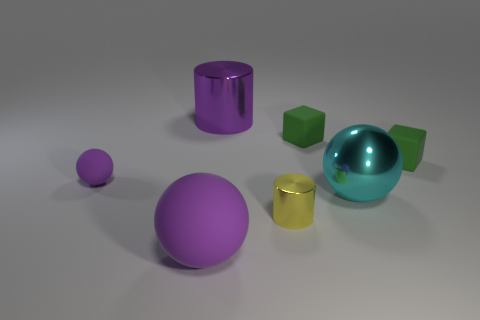What color is the big sphere behind the yellow thing?
Provide a succinct answer. Cyan. How many objects are large metallic things in front of the tiny sphere or yellow metallic cylinders?
Offer a very short reply. 2. What is the color of the metallic ball that is the same size as the purple shiny cylinder?
Offer a very short reply. Cyan. Are there more shiny things that are in front of the large cyan sphere than big cyan balls?
Make the answer very short. No. There is a large thing that is on the left side of the big cyan ball and behind the big purple rubber object; what material is it?
Your answer should be very brief. Metal. Do the small cube left of the big metallic sphere and the cylinder to the right of the big cylinder have the same color?
Provide a succinct answer. No. What number of other objects are the same size as the cyan metal object?
Provide a short and direct response. 2. Are there any small yellow objects to the left of the big purple object to the left of the metallic cylinder to the left of the tiny cylinder?
Make the answer very short. No. Does the large thing that is in front of the big cyan ball have the same material as the tiny yellow thing?
Offer a terse response. No. What is the color of the metallic thing that is the same shape as the tiny purple rubber object?
Your answer should be very brief. Cyan. 